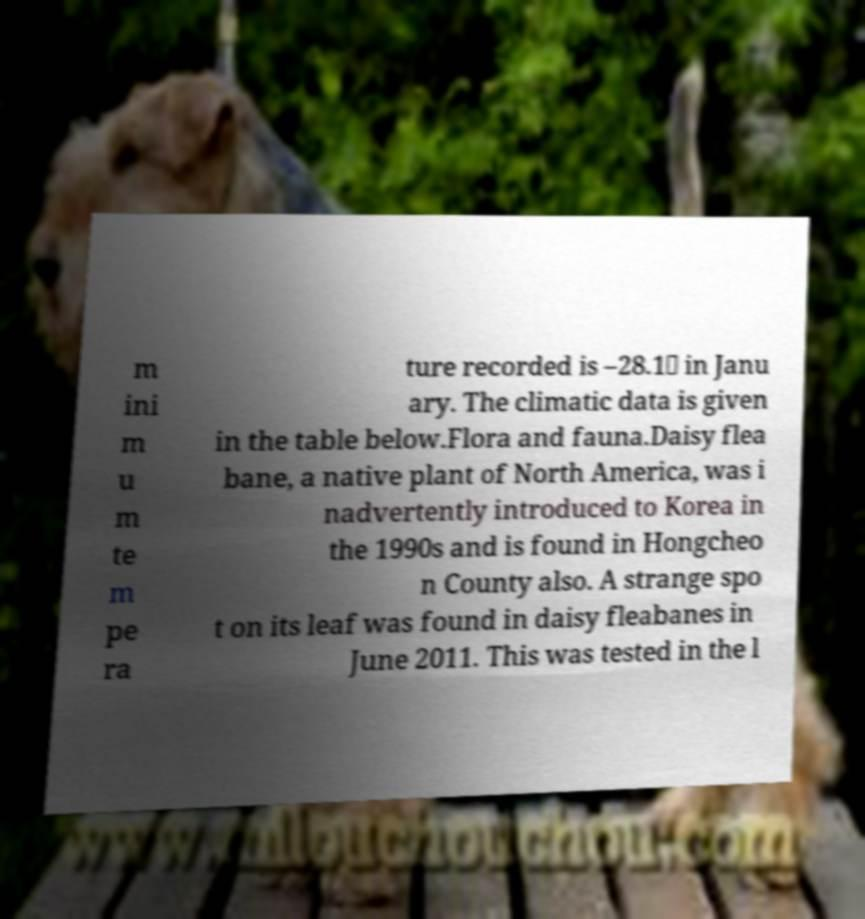What messages or text are displayed in this image? I need them in a readable, typed format. m ini m u m te m pe ra ture recorded is –28.1℃ in Janu ary. The climatic data is given in the table below.Flora and fauna.Daisy flea bane, a native plant of North America, was i nadvertently introduced to Korea in the 1990s and is found in Hongcheo n County also. A strange spo t on its leaf was found in daisy fleabanes in June 2011. This was tested in the l 